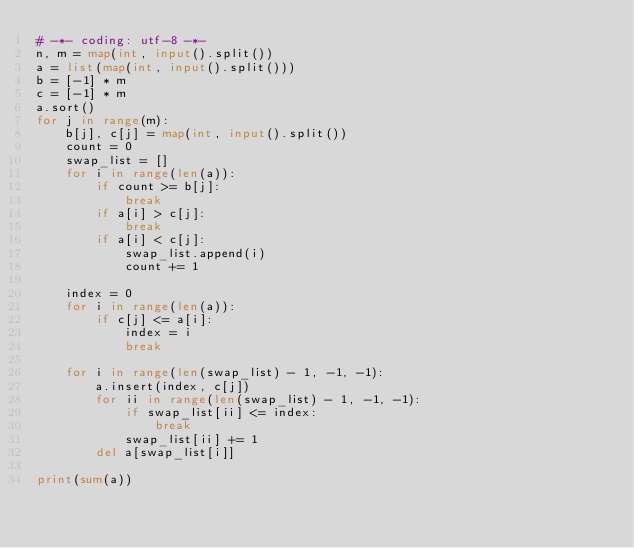<code> <loc_0><loc_0><loc_500><loc_500><_Python_># -*- coding: utf-8 -*-
n, m = map(int, input().split())
a = list(map(int, input().split()))
b = [-1] * m
c = [-1] * m
a.sort()
for j in range(m):
    b[j], c[j] = map(int, input().split())
    count = 0
    swap_list = []
    for i in range(len(a)):
        if count >= b[j]:
            break
        if a[i] > c[j]:
            break
        if a[i] < c[j]:
            swap_list.append(i)
            count += 1

    index = 0
    for i in range(len(a)):
        if c[j] <= a[i]:
            index = i
            break

    for i in range(len(swap_list) - 1, -1, -1):
        a.insert(index, c[j])
        for ii in range(len(swap_list) - 1, -1, -1):
            if swap_list[ii] <= index:
                break
            swap_list[ii] += 1
        del a[swap_list[i]]

print(sum(a))</code> 